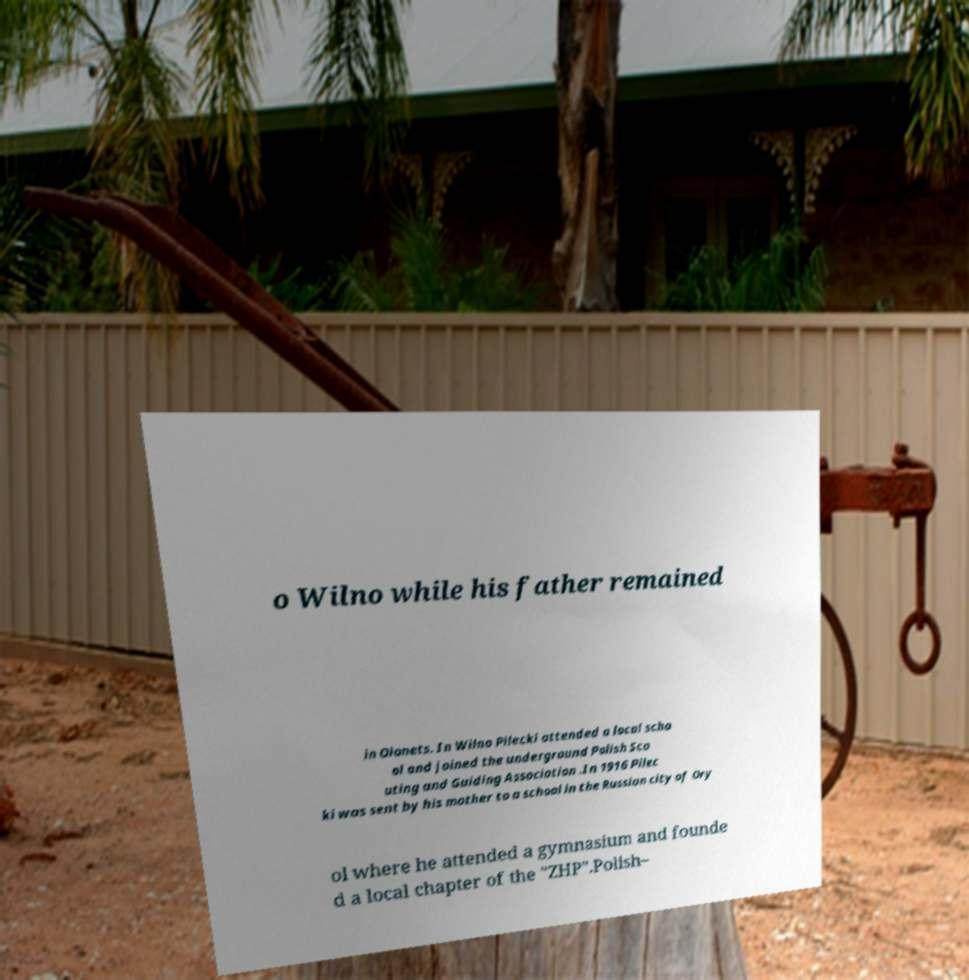Can you accurately transcribe the text from the provided image for me? o Wilno while his father remained in Olonets. In Wilno Pilecki attended a local scho ol and joined the underground Polish Sco uting and Guiding Association .In 1916 Pilec ki was sent by his mother to a school in the Russian city of Ory ol where he attended a gymnasium and founde d a local chapter of the "ZHP".Polish– 